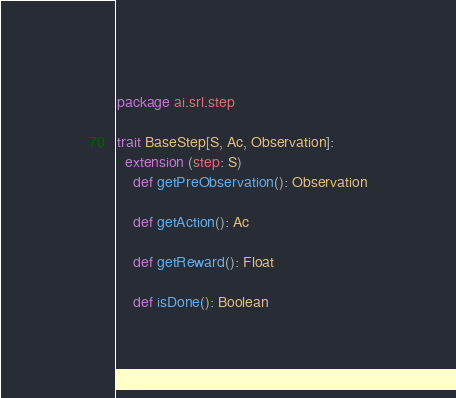<code> <loc_0><loc_0><loc_500><loc_500><_Scala_>package ai.srl.step

trait BaseStep[S, Ac, Observation]:
  extension (step: S)
    def getPreObservation(): Observation

    def getAction(): Ac

    def getReward(): Float

    def isDone(): Boolean
</code> 